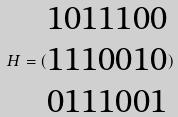<formula> <loc_0><loc_0><loc_500><loc_500>H = ( \begin{matrix} 1 0 1 1 1 0 0 \\ 1 1 1 0 0 1 0 \\ 0 1 1 1 0 0 1 \end{matrix} )</formula> 